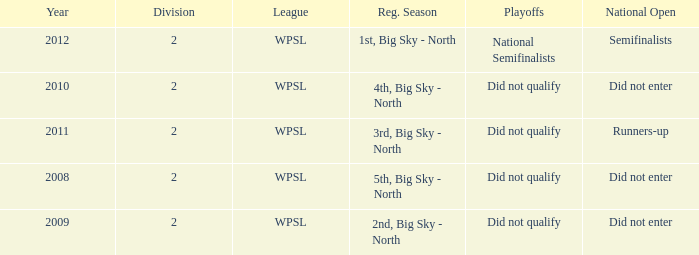What is the lowest division number? 2.0. 